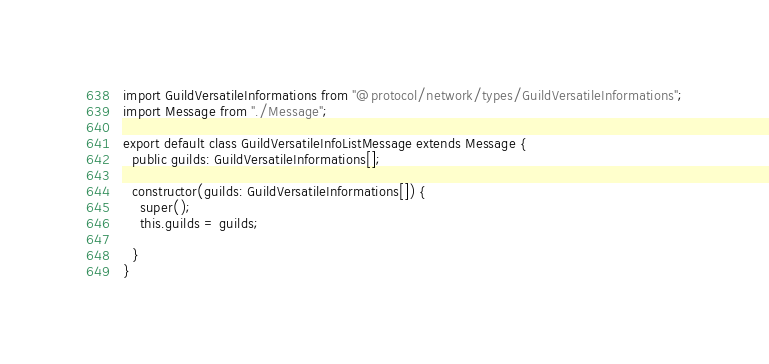Convert code to text. <code><loc_0><loc_0><loc_500><loc_500><_TypeScript_>import GuildVersatileInformations from "@protocol/network/types/GuildVersatileInformations";
import Message from "./Message";

export default class GuildVersatileInfoListMessage extends Message {
  public guilds: GuildVersatileInformations[];

  constructor(guilds: GuildVersatileInformations[]) {
    super();
    this.guilds = guilds;

  }
}
</code> 